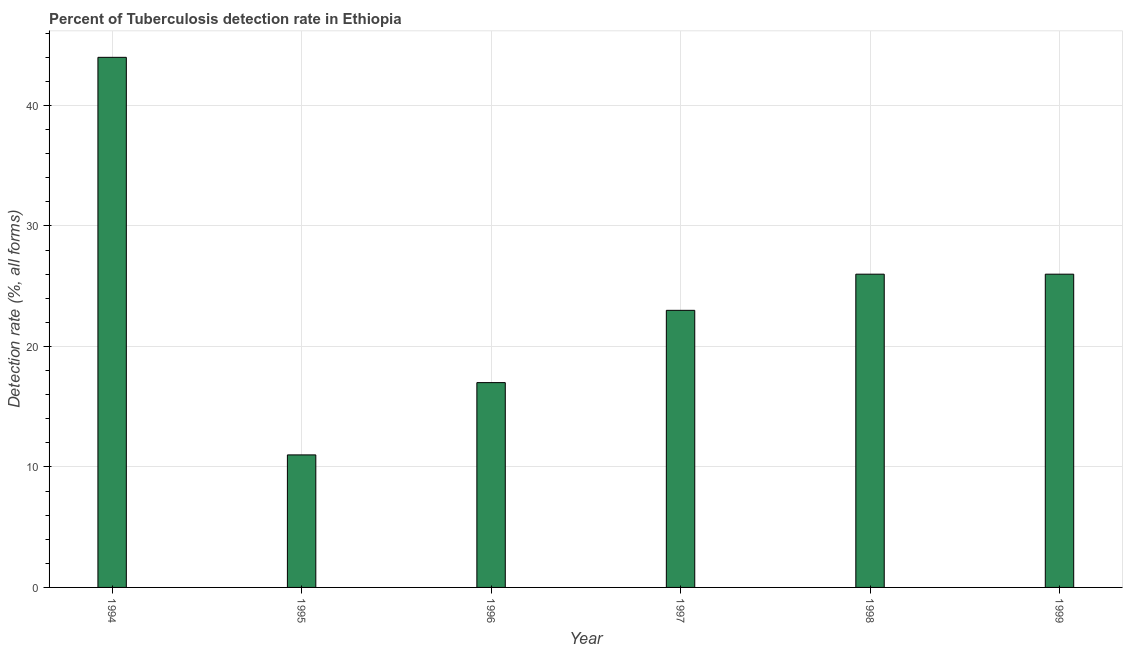What is the title of the graph?
Provide a short and direct response. Percent of Tuberculosis detection rate in Ethiopia. What is the label or title of the X-axis?
Give a very brief answer. Year. What is the label or title of the Y-axis?
Your response must be concise. Detection rate (%, all forms). Across all years, what is the minimum detection rate of tuberculosis?
Your answer should be very brief. 11. What is the sum of the detection rate of tuberculosis?
Your answer should be compact. 147. What is the average detection rate of tuberculosis per year?
Your answer should be very brief. 24. What is the ratio of the detection rate of tuberculosis in 1995 to that in 1998?
Keep it short and to the point. 0.42. Is the detection rate of tuberculosis in 1995 less than that in 1998?
Offer a terse response. Yes. Is the difference between the detection rate of tuberculosis in 1997 and 1999 greater than the difference between any two years?
Give a very brief answer. No. In how many years, is the detection rate of tuberculosis greater than the average detection rate of tuberculosis taken over all years?
Ensure brevity in your answer.  3. How many bars are there?
Make the answer very short. 6. Are all the bars in the graph horizontal?
Make the answer very short. No. How many years are there in the graph?
Provide a short and direct response. 6. What is the difference between two consecutive major ticks on the Y-axis?
Give a very brief answer. 10. What is the Detection rate (%, all forms) in 1998?
Your answer should be compact. 26. What is the Detection rate (%, all forms) in 1999?
Give a very brief answer. 26. What is the difference between the Detection rate (%, all forms) in 1994 and 1995?
Your response must be concise. 33. What is the difference between the Detection rate (%, all forms) in 1994 and 1997?
Keep it short and to the point. 21. What is the difference between the Detection rate (%, all forms) in 1994 and 1998?
Offer a terse response. 18. What is the difference between the Detection rate (%, all forms) in 1995 and 1997?
Ensure brevity in your answer.  -12. What is the difference between the Detection rate (%, all forms) in 1995 and 1998?
Your response must be concise. -15. What is the difference between the Detection rate (%, all forms) in 1996 and 1997?
Make the answer very short. -6. What is the difference between the Detection rate (%, all forms) in 1996 and 1999?
Your answer should be compact. -9. What is the difference between the Detection rate (%, all forms) in 1997 and 1999?
Your response must be concise. -3. What is the ratio of the Detection rate (%, all forms) in 1994 to that in 1995?
Provide a short and direct response. 4. What is the ratio of the Detection rate (%, all forms) in 1994 to that in 1996?
Offer a terse response. 2.59. What is the ratio of the Detection rate (%, all forms) in 1994 to that in 1997?
Your response must be concise. 1.91. What is the ratio of the Detection rate (%, all forms) in 1994 to that in 1998?
Provide a short and direct response. 1.69. What is the ratio of the Detection rate (%, all forms) in 1994 to that in 1999?
Your response must be concise. 1.69. What is the ratio of the Detection rate (%, all forms) in 1995 to that in 1996?
Keep it short and to the point. 0.65. What is the ratio of the Detection rate (%, all forms) in 1995 to that in 1997?
Provide a succinct answer. 0.48. What is the ratio of the Detection rate (%, all forms) in 1995 to that in 1998?
Offer a terse response. 0.42. What is the ratio of the Detection rate (%, all forms) in 1995 to that in 1999?
Ensure brevity in your answer.  0.42. What is the ratio of the Detection rate (%, all forms) in 1996 to that in 1997?
Your response must be concise. 0.74. What is the ratio of the Detection rate (%, all forms) in 1996 to that in 1998?
Offer a terse response. 0.65. What is the ratio of the Detection rate (%, all forms) in 1996 to that in 1999?
Offer a terse response. 0.65. What is the ratio of the Detection rate (%, all forms) in 1997 to that in 1998?
Offer a terse response. 0.89. What is the ratio of the Detection rate (%, all forms) in 1997 to that in 1999?
Provide a succinct answer. 0.89. 